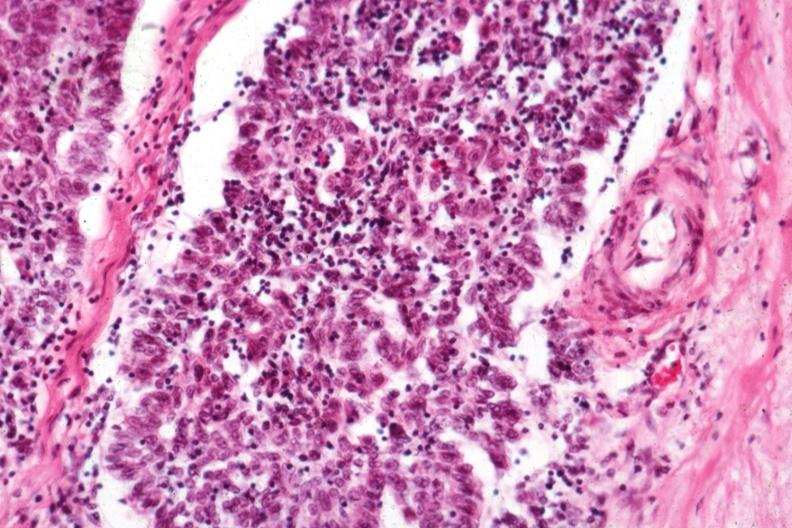s female reproductive present?
Answer the question using a single word or phrase. No 